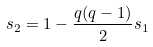Convert formula to latex. <formula><loc_0><loc_0><loc_500><loc_500>s _ { 2 } = 1 - \frac { q ( q - 1 ) } { 2 } s _ { 1 }</formula> 